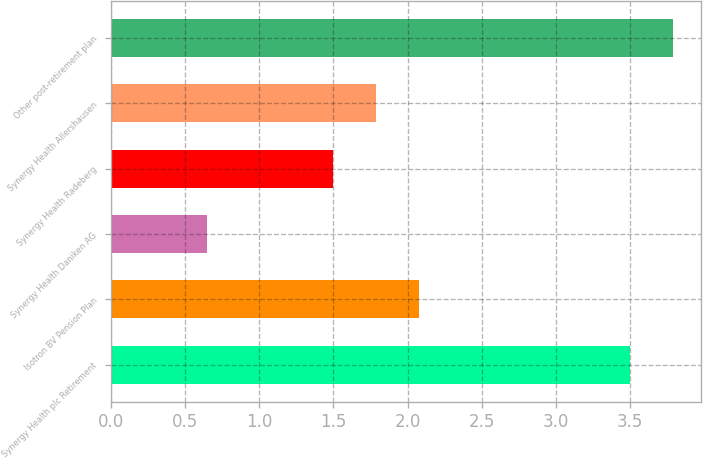Convert chart. <chart><loc_0><loc_0><loc_500><loc_500><bar_chart><fcel>Synergy Health plc Retirement<fcel>Isotron BV Pension Plan<fcel>Synergy Health Daniken AG<fcel>Synergy Health Radeberg<fcel>Synergy Health Allershausen<fcel>Other post-retirement plan<nl><fcel>3.5<fcel>2.08<fcel>0.65<fcel>1.5<fcel>1.79<fcel>3.79<nl></chart> 